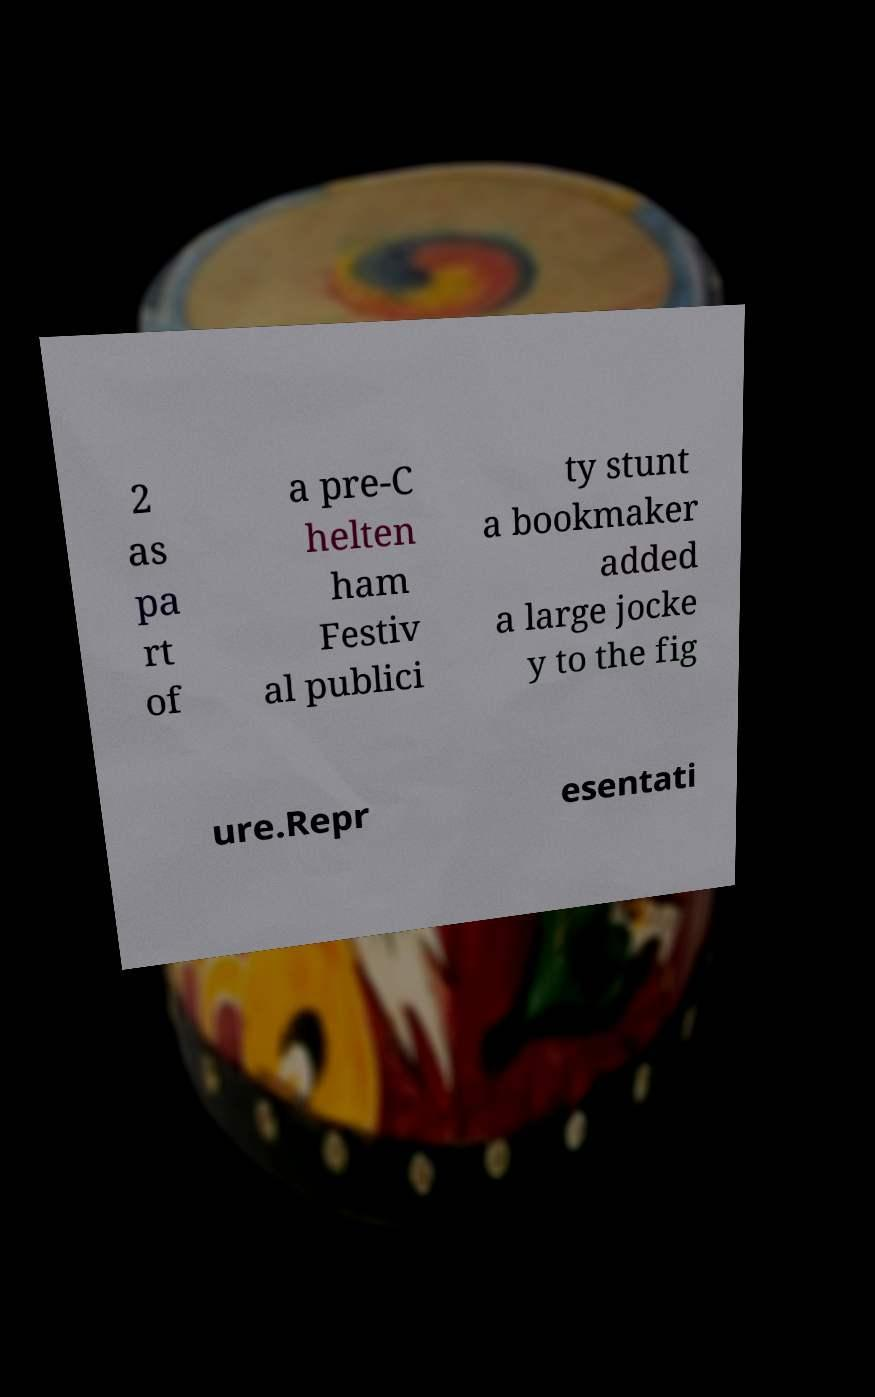Please identify and transcribe the text found in this image. 2 as pa rt of a pre-C helten ham Festiv al publici ty stunt a bookmaker added a large jocke y to the fig ure.Repr esentati 